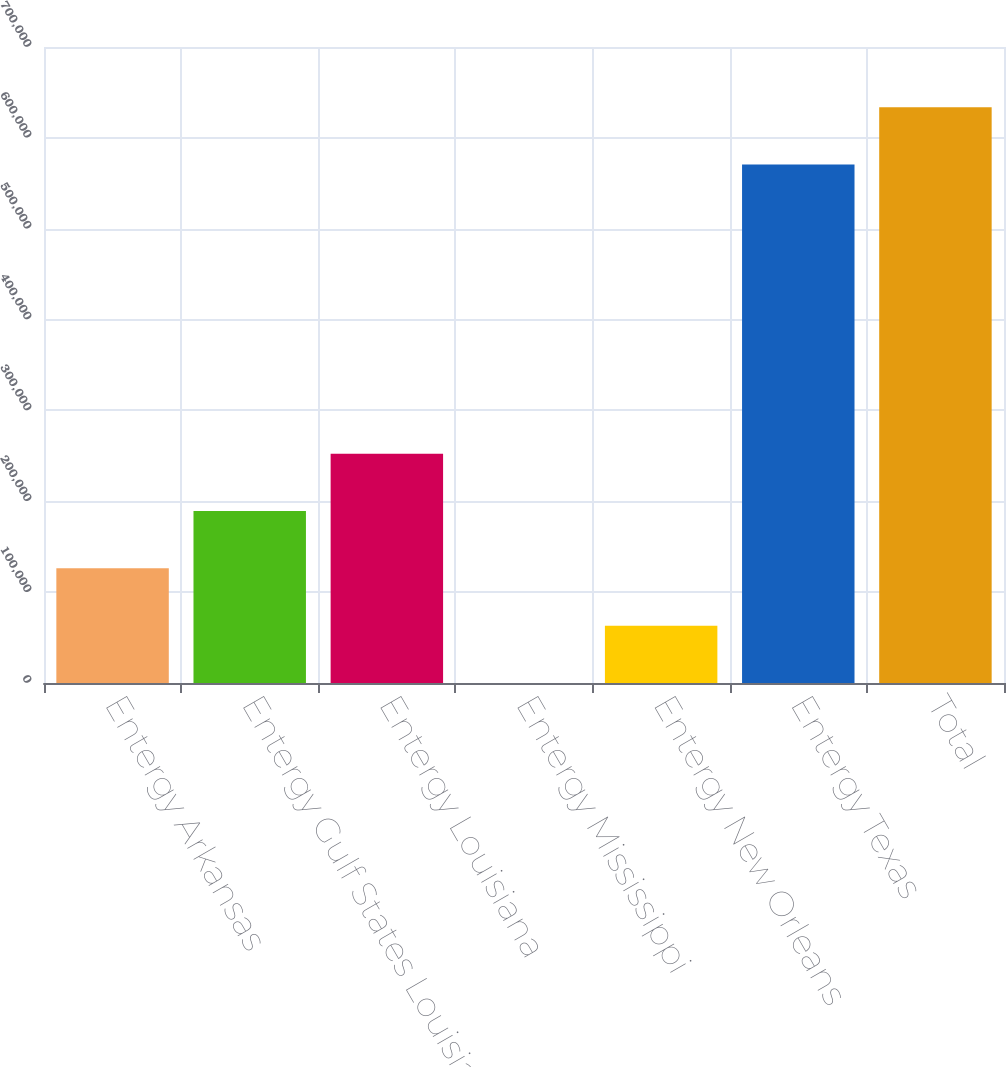Convert chart. <chart><loc_0><loc_0><loc_500><loc_500><bar_chart><fcel>Entergy Arkansas<fcel>Entergy Gulf States Louisiana<fcel>Entergy Louisiana<fcel>Entergy Mississippi<fcel>Entergy New Orleans<fcel>Entergy Texas<fcel>Total<nl><fcel>126161<fcel>189224<fcel>252287<fcel>35<fcel>63098<fcel>570590<fcel>633653<nl></chart> 